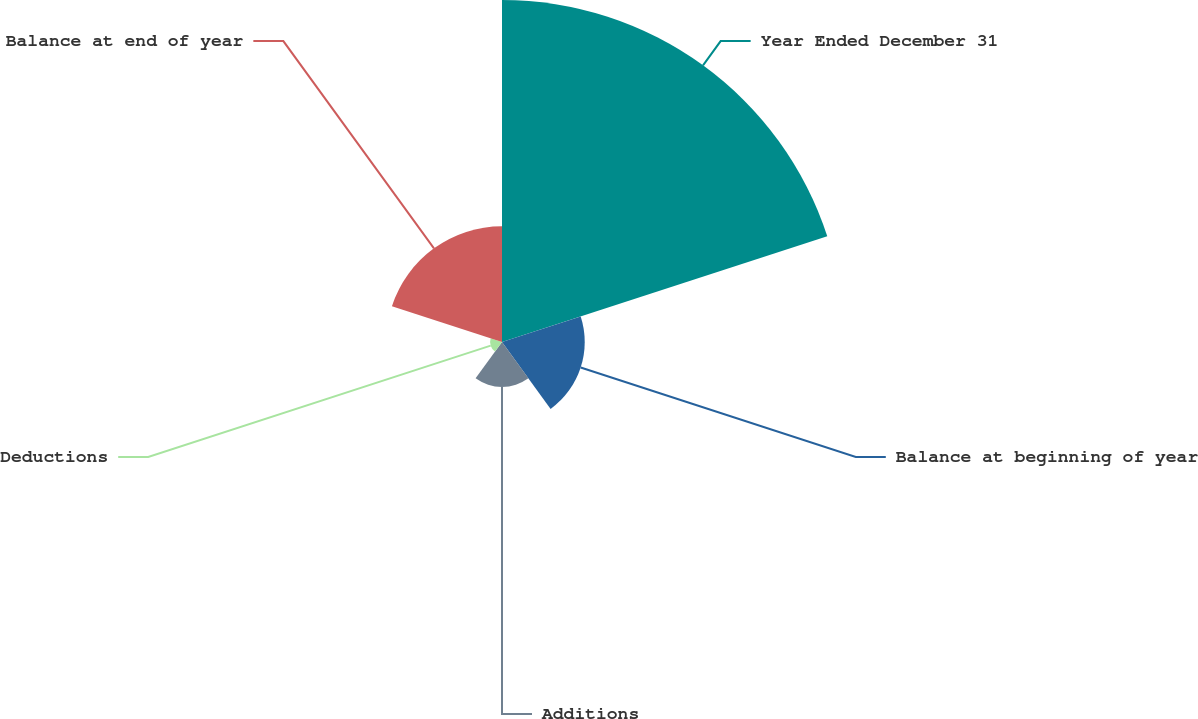Convert chart to OTSL. <chart><loc_0><loc_0><loc_500><loc_500><pie_chart><fcel>Year Ended December 31<fcel>Balance at beginning of year<fcel>Additions<fcel>Deductions<fcel>Balance at end of year<nl><fcel>57.26%<fcel>13.85%<fcel>7.52%<fcel>1.99%<fcel>19.38%<nl></chart> 